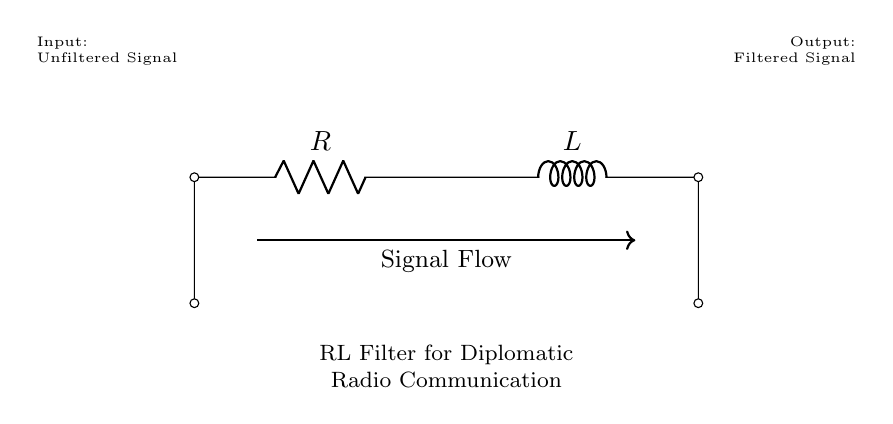What components are used in this circuit? The circuit consists of a resistor and an inductor, which are the primary components depicted.
Answer: Resistor and Inductor What is the primary function of this circuit? The circuit functions as a filter that processes an unfiltered signal to produce a filtered signal. This can be inferred from the labels indicating input and output signals on the circuit diagram.
Answer: Filter What is the direction of the signal flow in this circuit? The signal flows from the input, where the unfiltered signal is applied, through the resistor and inductor, and exits as a filtered signal. The arrow indicates the direction clearly.
Answer: Left to right What type of circuit is this categorized as? This is categorized as an RL filter circuit, designed specifically for handling signals. This is indicated by the presence of a resistor and an inductor in series.
Answer: RL filter How does the inductor affect the frequency response of the circuit? The inductor introduces inductive reactance, which affects the impedance of the circuit at different frequencies; it typically allows lower frequencies to pass while filtering higher frequencies. This property is fundamental to how RL circuits operate.
Answer: Filters higher frequencies What happens to the input signal when it passes through the circuit? The input signal, which is unfiltered, undergoes alterations in frequency components as it passes through the inductor and resistor, resulting in a modified output signal that is less noisy or more selective.
Answer: It gets filtered 